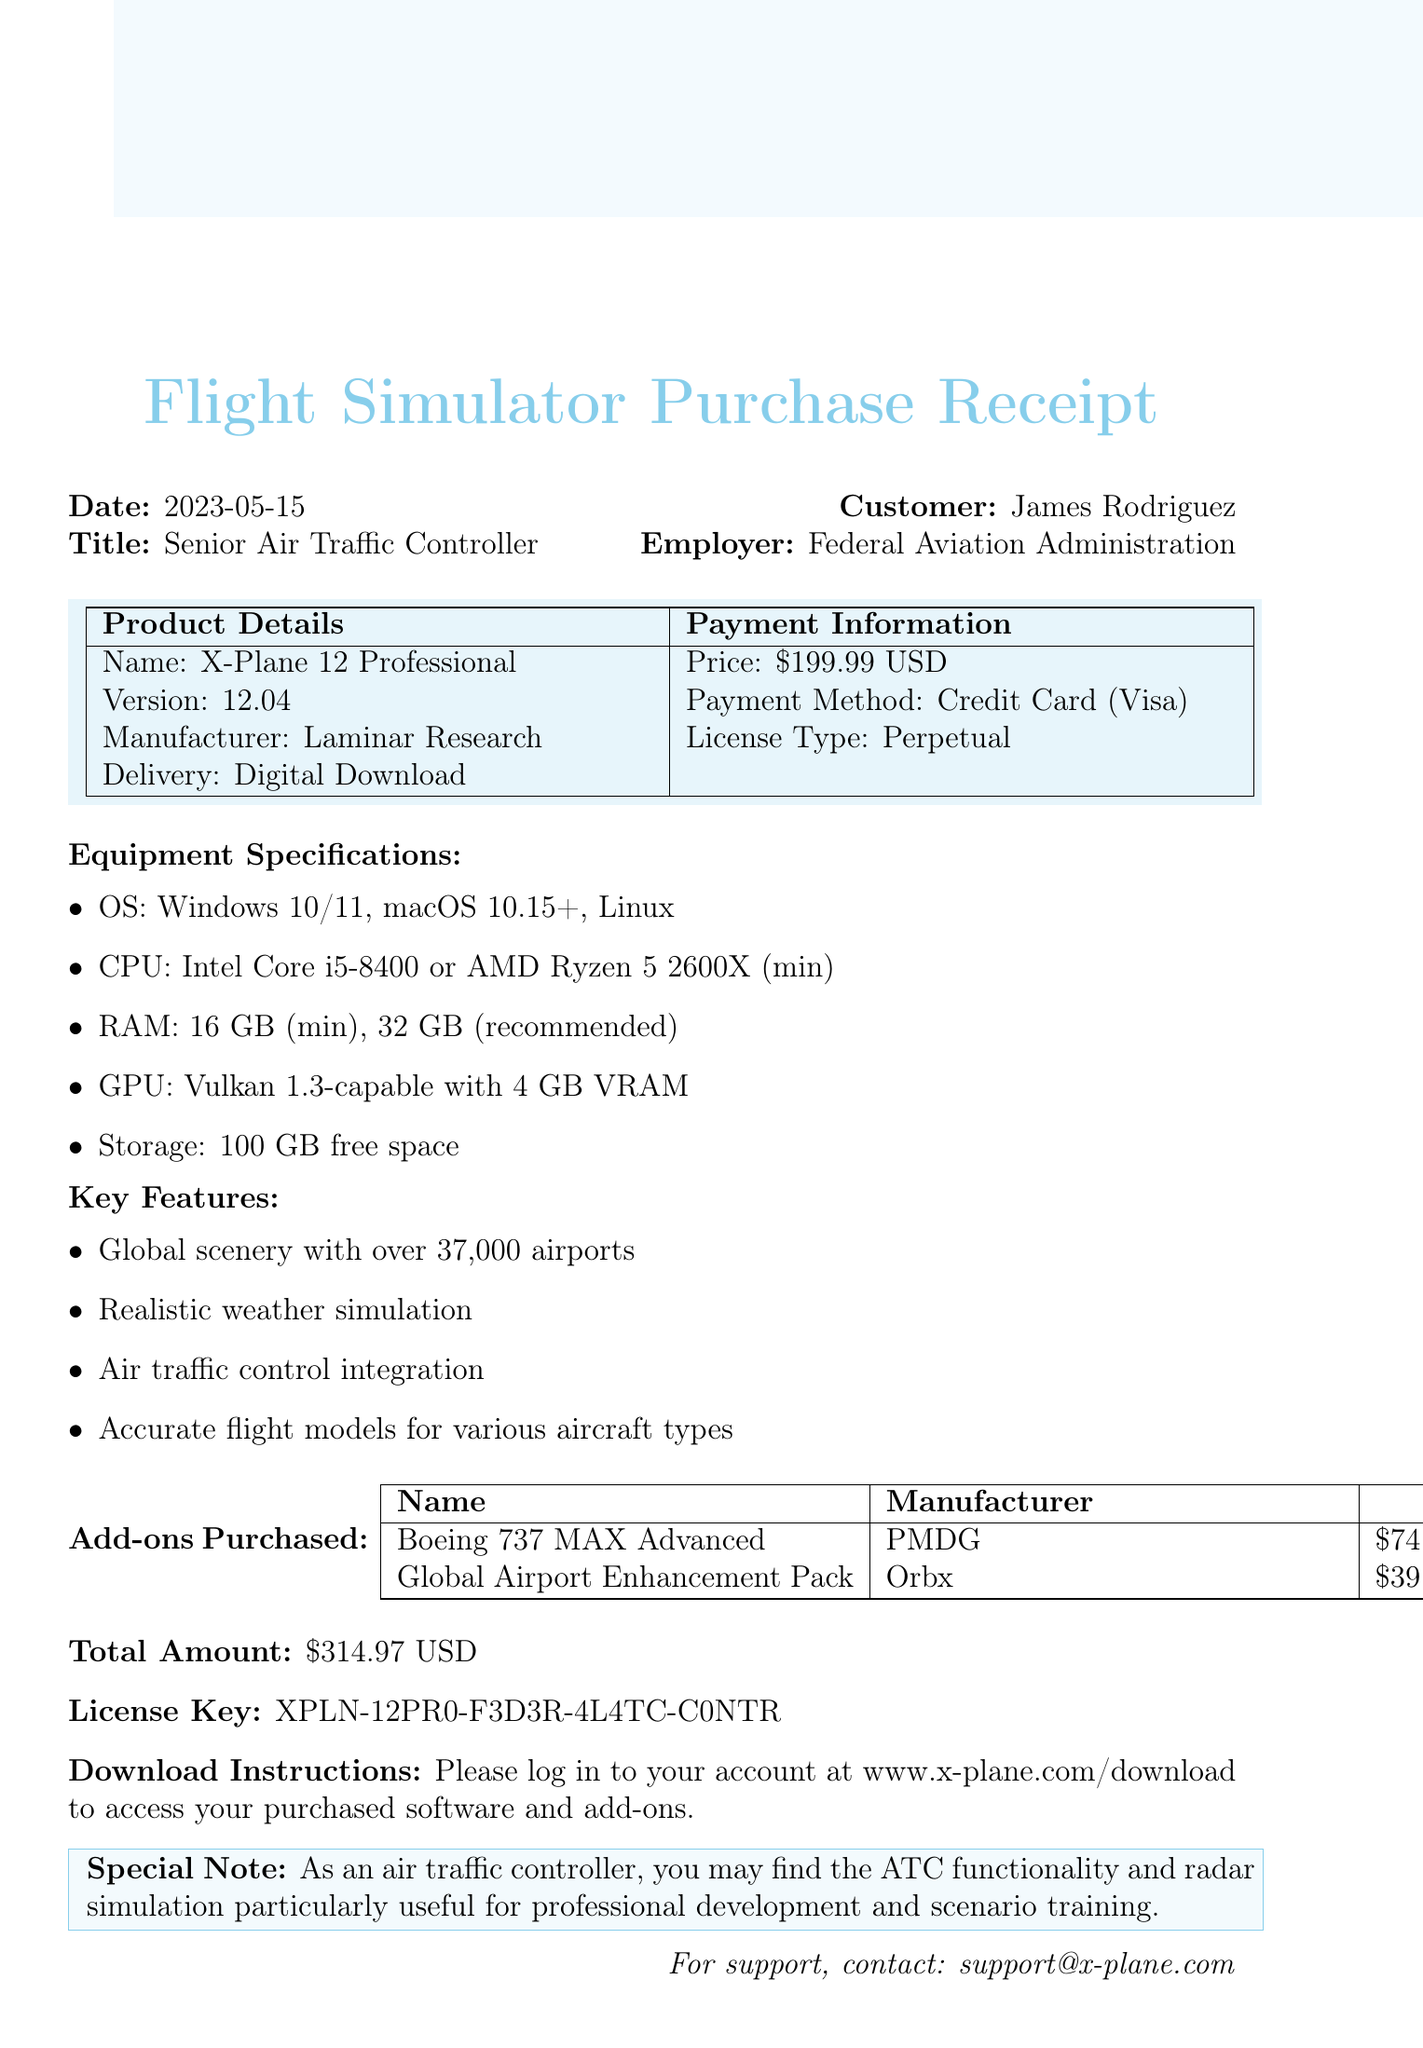What is the transaction ID? The transaction ID is stated clearly in the document, specifically as "FS-2023-05-15-0789".
Answer: FS-2023-05-15-0789 Who is the customer? The customer name is provided in the document as "James Rodriguez".
Answer: James Rodriguez What is the price of the software? The document lists the price of the software as "$199.99 USD".
Answer: $199.99 USD Which operating systems are supported? The supported operating systems are mentioned in the specifications section of the document.
Answer: Windows 10/11, macOS 10.15+, Linux What is the total amount spent including add-ons? The total amount is provided at the end of the document, summing the software price and add-ons.
Answer: $314.97 USD What is the recommended RAM for optimal performance? The document specifies the recommended RAM requirement in the equipment specifications.
Answer: 32 GB Which add-on is manufactured by PMDG? The document identifies add-ons purchased and which manufacturer makes each.
Answer: Boeing 737 MAX Advanced What type of license was purchased for the software? The license type is detailed in the product details section of the document.
Answer: Perpetual What contact information is provided for support? The document includes a specific email address for support queries.
Answer: support@x-plane.com 